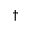Convert formula to latex. <formula><loc_0><loc_0><loc_500><loc_500>\dagger</formula> 